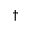Convert formula to latex. <formula><loc_0><loc_0><loc_500><loc_500>\dagger</formula> 